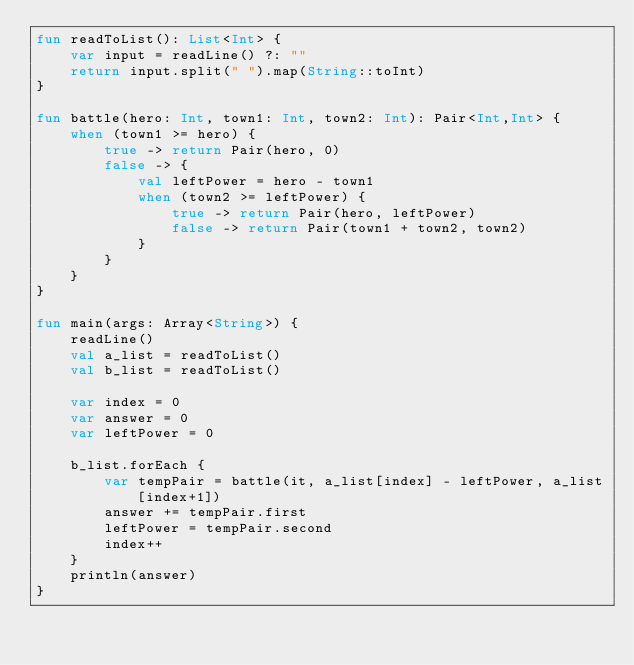<code> <loc_0><loc_0><loc_500><loc_500><_Kotlin_>fun readToList(): List<Int> {
    var input = readLine() ?: ""
    return input.split(" ").map(String::toInt)
}

fun battle(hero: Int, town1: Int, town2: Int): Pair<Int,Int> {
    when (town1 >= hero) {
        true -> return Pair(hero, 0)
        false -> {
            val leftPower = hero - town1
            when (town2 >= leftPower) {
                true -> return Pair(hero, leftPower)
                false -> return Pair(town1 + town2, town2)
            }
        }
    }
}

fun main(args: Array<String>) {
    readLine()
    val a_list = readToList()
    val b_list = readToList()

    var index = 0
    var answer = 0
    var leftPower = 0

    b_list.forEach {
        var tempPair = battle(it, a_list[index] - leftPower, a_list[index+1])
        answer += tempPair.first
        leftPower = tempPair.second
        index++
    }
    println(answer)
}</code> 